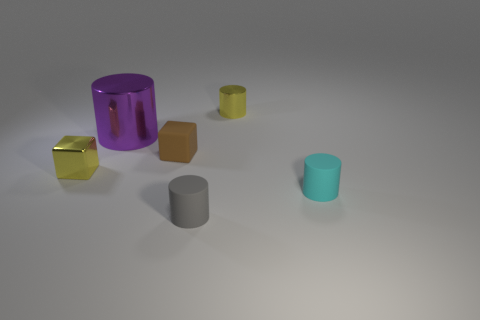Does the gray rubber object have the same size as the yellow shiny cube?
Provide a short and direct response. Yes. There is a object that is both to the left of the brown matte block and in front of the tiny brown thing; what material is it?
Your answer should be compact. Metal. How many other purple things have the same shape as the purple shiny thing?
Ensure brevity in your answer.  0. There is a yellow thing that is behind the matte block; what is it made of?
Provide a short and direct response. Metal. Are there fewer tiny yellow cylinders that are on the left side of the small metal cylinder than large purple metallic objects?
Keep it short and to the point. Yes. Do the gray matte thing and the small brown rubber object have the same shape?
Your response must be concise. No. Is there any other thing that is the same shape as the big purple thing?
Make the answer very short. Yes. Are any red matte blocks visible?
Your response must be concise. No. Is the shape of the gray thing the same as the matte object that is behind the small cyan rubber cylinder?
Ensure brevity in your answer.  No. There is a gray object that is to the right of the tiny shiny object in front of the big metal thing; what is it made of?
Your answer should be compact. Rubber. 